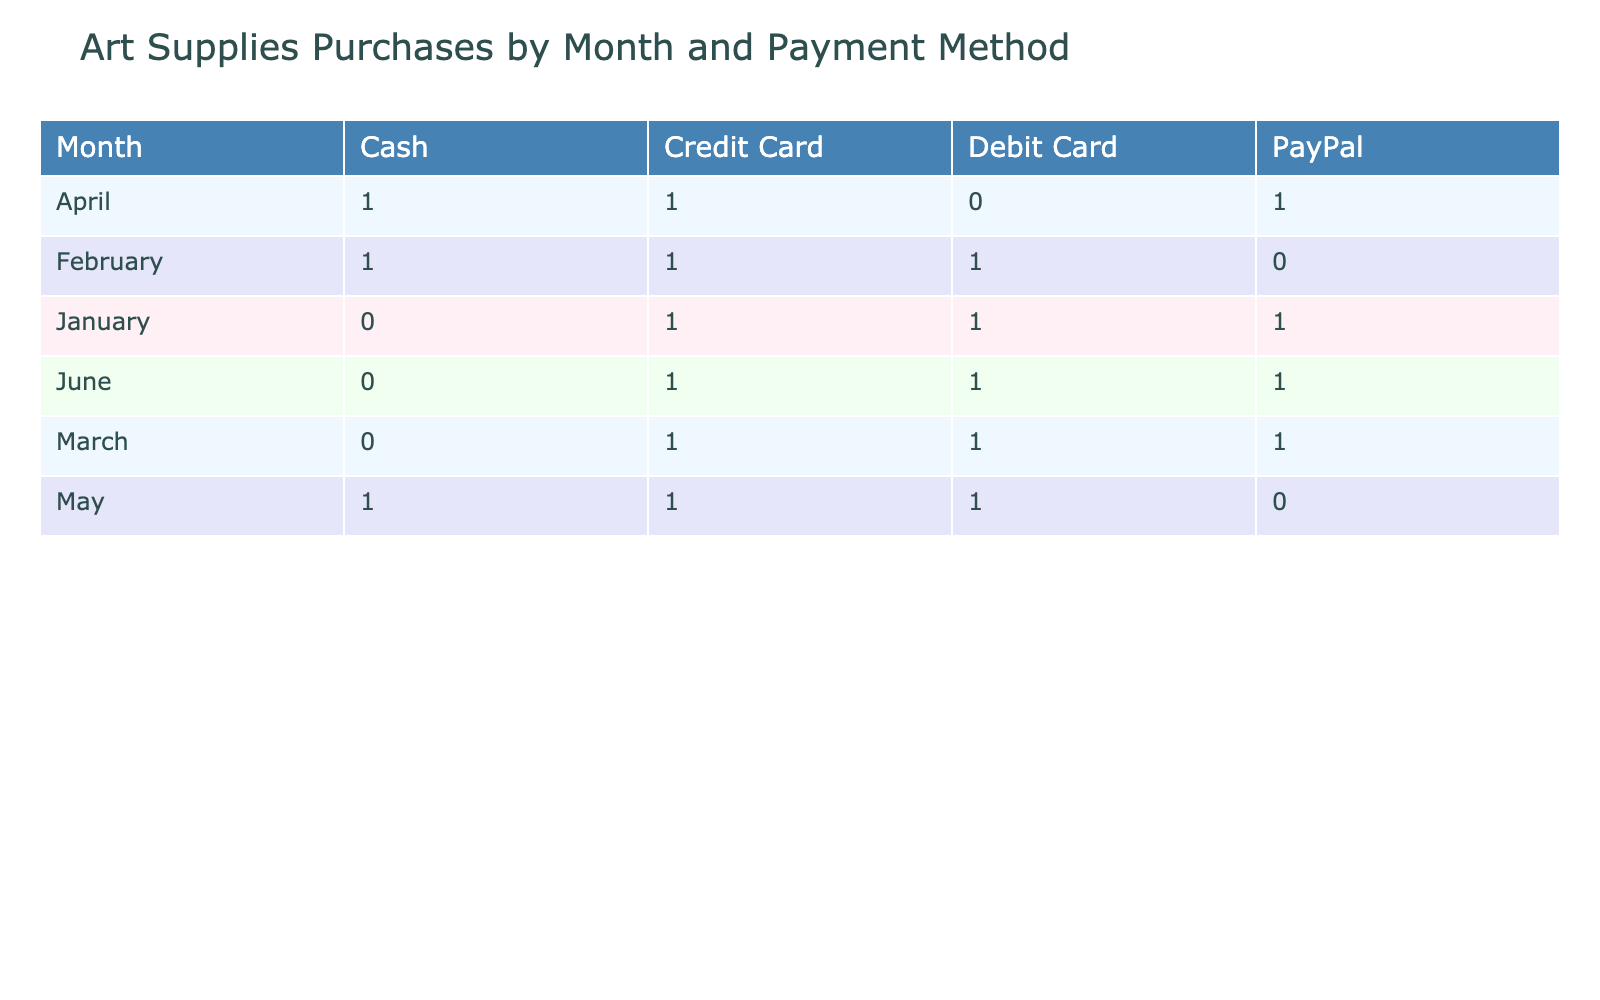What payment method was used the most in January? The table shows the count of art supplies purchases for each payment method in January. In January, there are purchases recorded for three methods: Credit Card (1), PayPal (1), and Debit Card (1). Since all methods have the same count, there's no distinct highest method.
Answer: No distinct highest How many supplies were purchased using PayPal in April? In April, the table indicates that there were two purchases made using PayPal: "Art Spectrum Pastels" and the count of these purchases is 1.
Answer: 1 Which month had the highest number of total purchases? To determine the month with the highest number of purchases, we aggregate the counts for each month. January has 3 (1+1+1), February has 3 (1+1+1), March has 3 (1+1+1), April has 3 (1+2+1), May has 3 (1+1+1), and June has 3 (1+1+1). All months have the same total purchases.
Answer: All months are equal Was cash used for purchases in every month? The table shows the payment methods used in each month. Cash was not used in February or March, indicating that it was not used in every month.
Answer: No What was the total number of art supplies purchased via Debit Card from January to June? The table provides counts of purchases made with the Debit Card across the months. There are 1 purchase in January, 1 in February, 1 in March, 1 in May, and 1 in June. Adding these gives a total of 5 purchases.
Answer: 5 In which month was the Credit Card used the least? Reviewing the table, we can see that in January, February, March, April, May, and June, the counts for Credit Card usage are 1, 1, 1, 1, 1, and 2 respectively. The least usage is clearly January, February, March, and April with only 1 each.
Answer: January, February, March, and April How many distinct payment methods were used in February? Looking at the February section of the table, we note the different methods used: Credit Card, Debit Card, and Cash. Each of these methods was used one time, which means there were three distinct payment methods utilized that month.
Answer: 3 Which payment method had the least purchases overall? By analyzing the total purchase counts for each payment method, we find that over six months, each method had varied counts. However, the Debit Card total is 5 counts, and Cash is also 5; comparing these overall, both had the least counts tied against others that had higher counts.
Answer: Debit Card and Cash are tied for least What is the difference in total purchases between Credit Card and PayPal? By summing therows for both payment methods: Credit Card has 6 (1+1+1+1+1+2) over the months, while PayPal has 5 (1+1+1+1+1) separately. Hence, the difference is 6 - 5 = 1, indicating how many more were credited to Credit Card purchases.
Answer: 1 